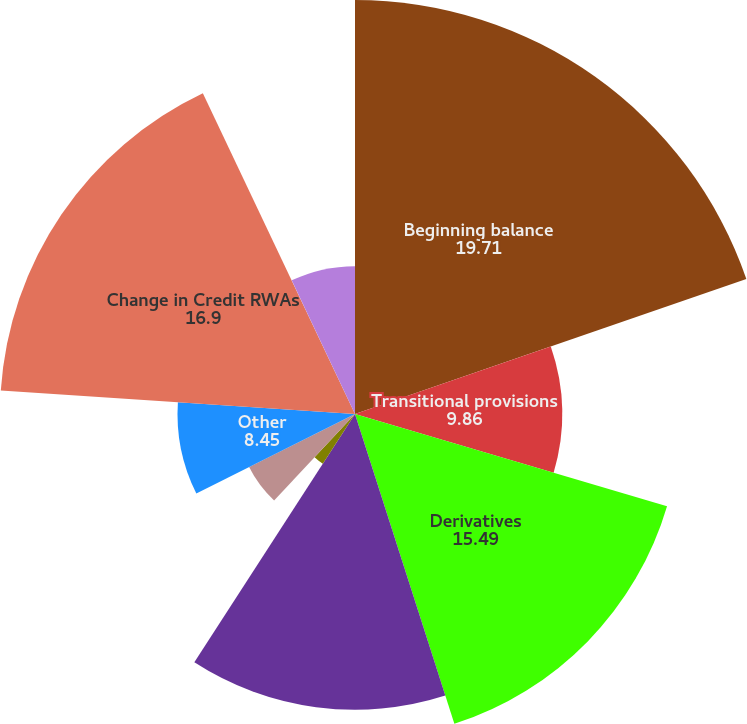<chart> <loc_0><loc_0><loc_500><loc_500><pie_chart><fcel>Beginning balance<fcel>Transitional provisions<fcel>Derivatives<fcel>Commitments guarantees and<fcel>Securities financing<fcel>Equity investments<fcel>Other<fcel>Change in Credit RWAs<fcel>Regulatory VaR<fcel>Stressed VaR<nl><fcel>19.71%<fcel>9.86%<fcel>15.49%<fcel>14.08%<fcel>2.82%<fcel>5.64%<fcel>8.45%<fcel>16.9%<fcel>0.01%<fcel>7.04%<nl></chart> 